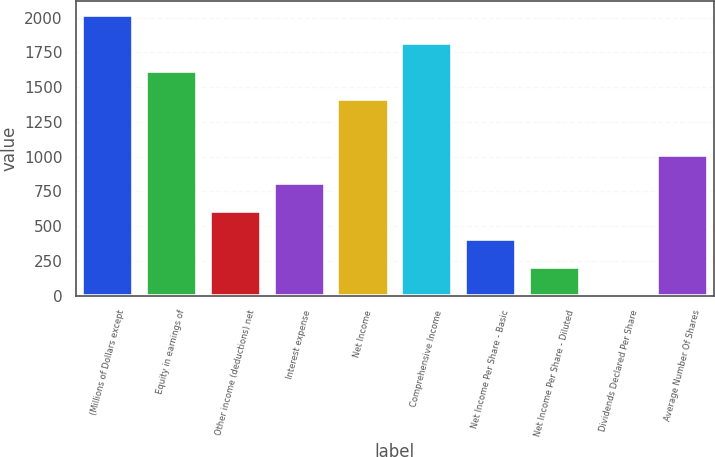Convert chart to OTSL. <chart><loc_0><loc_0><loc_500><loc_500><bar_chart><fcel>(Millions of Dollars except<fcel>Equity in earnings of<fcel>Other income (deductions) net<fcel>Interest expense<fcel>Net Income<fcel>Comprehensive Income<fcel>Net Income Per Share - Basic<fcel>Net Income Per Share - Diluted<fcel>Dividends Declared Per Share<fcel>Average Number Of Shares<nl><fcel>2015<fcel>1612.52<fcel>606.32<fcel>807.56<fcel>1411.28<fcel>1813.76<fcel>405.08<fcel>203.84<fcel>2.6<fcel>1008.8<nl></chart> 